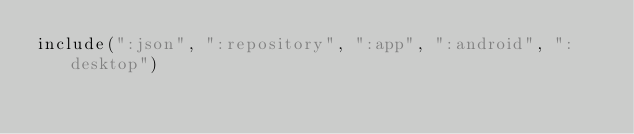Convert code to text. <code><loc_0><loc_0><loc_500><loc_500><_Kotlin_>include(":json", ":repository", ":app", ":android", ":desktop")
</code> 